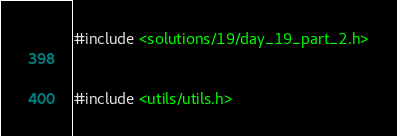<code> <loc_0><loc_0><loc_500><loc_500><_C++_>#include <solutions/19/day_19_part_2.h>


#include <utils/utils.h>



</code> 